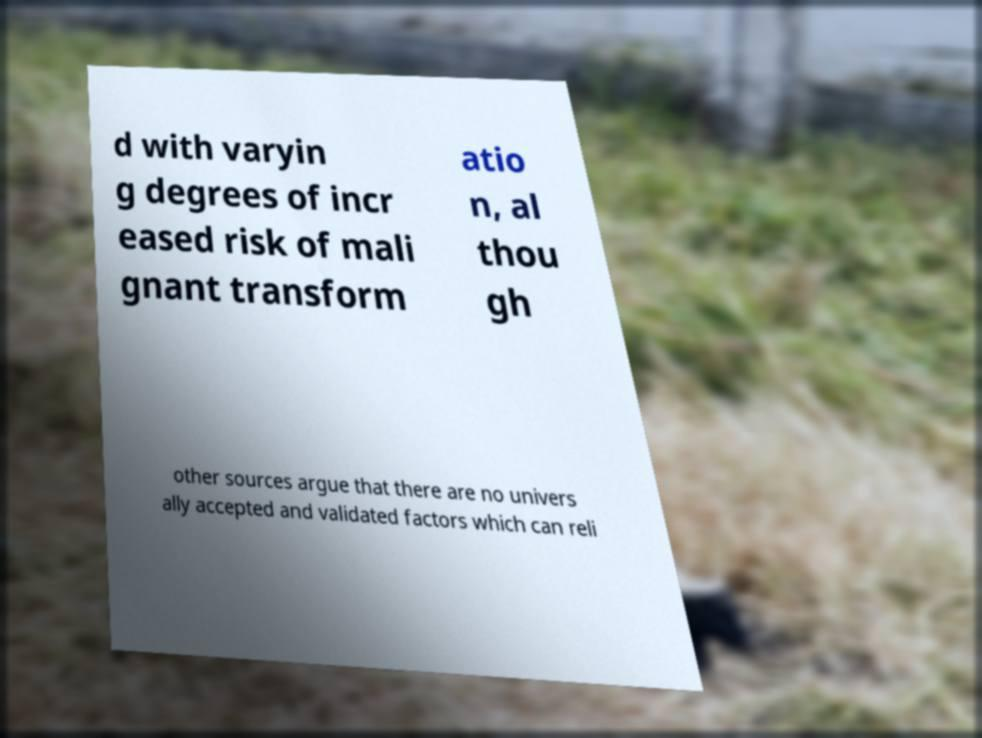Please identify and transcribe the text found in this image. d with varyin g degrees of incr eased risk of mali gnant transform atio n, al thou gh other sources argue that there are no univers ally accepted and validated factors which can reli 